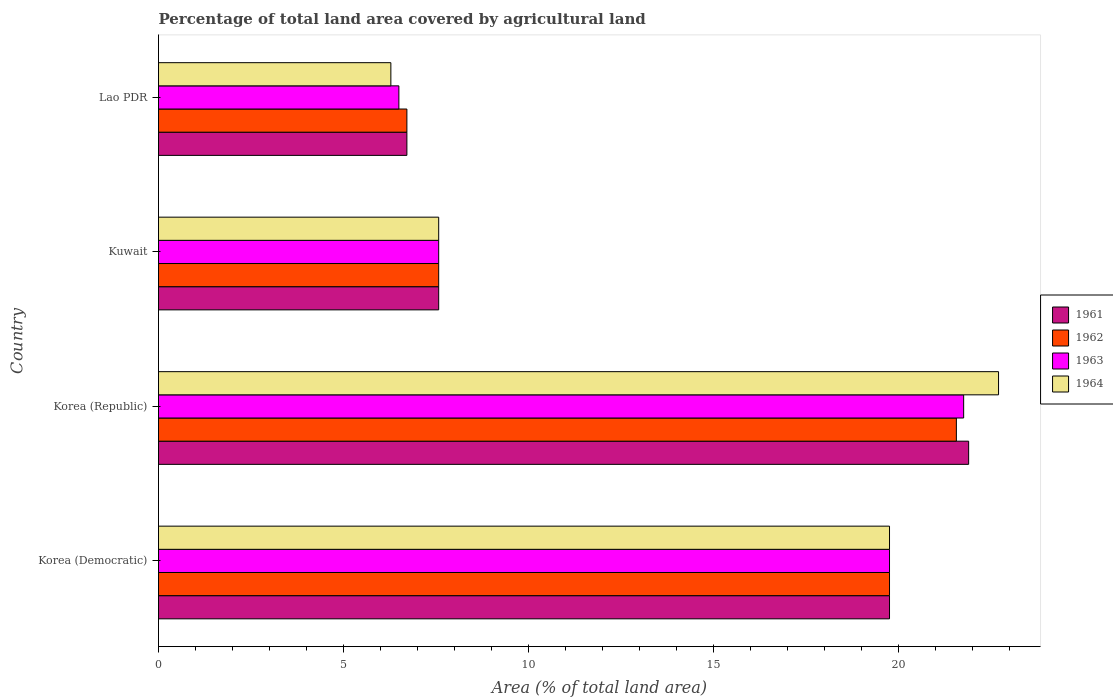How many different coloured bars are there?
Offer a very short reply. 4. Are the number of bars on each tick of the Y-axis equal?
Give a very brief answer. Yes. How many bars are there on the 1st tick from the bottom?
Provide a short and direct response. 4. What is the label of the 4th group of bars from the top?
Provide a succinct answer. Korea (Democratic). In how many cases, is the number of bars for a given country not equal to the number of legend labels?
Ensure brevity in your answer.  0. What is the percentage of agricultural land in 1963 in Kuwait?
Keep it short and to the point. 7.58. Across all countries, what is the maximum percentage of agricultural land in 1963?
Your response must be concise. 21.77. Across all countries, what is the minimum percentage of agricultural land in 1963?
Provide a short and direct response. 6.5. In which country was the percentage of agricultural land in 1961 maximum?
Your answer should be very brief. Korea (Republic). In which country was the percentage of agricultural land in 1964 minimum?
Provide a succinct answer. Lao PDR. What is the total percentage of agricultural land in 1964 in the graph?
Your answer should be compact. 56.34. What is the difference between the percentage of agricultural land in 1964 in Korea (Republic) and that in Lao PDR?
Make the answer very short. 16.43. What is the difference between the percentage of agricultural land in 1961 in Lao PDR and the percentage of agricultural land in 1963 in Kuwait?
Keep it short and to the point. -0.86. What is the average percentage of agricultural land in 1963 per country?
Offer a terse response. 13.9. What is the difference between the percentage of agricultural land in 1963 and percentage of agricultural land in 1964 in Korea (Republic)?
Keep it short and to the point. -0.94. In how many countries, is the percentage of agricultural land in 1964 greater than 5 %?
Provide a succinct answer. 4. What is the ratio of the percentage of agricultural land in 1962 in Korea (Democratic) to that in Kuwait?
Your answer should be very brief. 2.61. Is the percentage of agricultural land in 1962 in Korea (Democratic) less than that in Lao PDR?
Provide a short and direct response. No. What is the difference between the highest and the second highest percentage of agricultural land in 1963?
Your answer should be compact. 2. What is the difference between the highest and the lowest percentage of agricultural land in 1962?
Give a very brief answer. 14.86. What does the 3rd bar from the top in Korea (Democratic) represents?
Your response must be concise. 1962. What does the 4th bar from the bottom in Kuwait represents?
Keep it short and to the point. 1964. Are all the bars in the graph horizontal?
Give a very brief answer. Yes. How many countries are there in the graph?
Give a very brief answer. 4. What is the difference between two consecutive major ticks on the X-axis?
Keep it short and to the point. 5. How are the legend labels stacked?
Ensure brevity in your answer.  Vertical. What is the title of the graph?
Provide a short and direct response. Percentage of total land area covered by agricultural land. What is the label or title of the X-axis?
Give a very brief answer. Area (% of total land area). What is the Area (% of total land area) in 1961 in Korea (Democratic)?
Offer a very short reply. 19.77. What is the Area (% of total land area) of 1962 in Korea (Democratic)?
Provide a succinct answer. 19.77. What is the Area (% of total land area) in 1963 in Korea (Democratic)?
Give a very brief answer. 19.77. What is the Area (% of total land area) in 1964 in Korea (Democratic)?
Provide a succinct answer. 19.77. What is the Area (% of total land area) of 1961 in Korea (Republic)?
Offer a very short reply. 21.91. What is the Area (% of total land area) of 1962 in Korea (Republic)?
Your answer should be very brief. 21.57. What is the Area (% of total land area) in 1963 in Korea (Republic)?
Make the answer very short. 21.77. What is the Area (% of total land area) in 1964 in Korea (Republic)?
Provide a succinct answer. 22.71. What is the Area (% of total land area) of 1961 in Kuwait?
Keep it short and to the point. 7.58. What is the Area (% of total land area) of 1962 in Kuwait?
Provide a succinct answer. 7.58. What is the Area (% of total land area) in 1963 in Kuwait?
Your response must be concise. 7.58. What is the Area (% of total land area) of 1964 in Kuwait?
Give a very brief answer. 7.58. What is the Area (% of total land area) in 1961 in Lao PDR?
Your answer should be compact. 6.72. What is the Area (% of total land area) of 1962 in Lao PDR?
Ensure brevity in your answer.  6.72. What is the Area (% of total land area) in 1963 in Lao PDR?
Offer a terse response. 6.5. What is the Area (% of total land area) in 1964 in Lao PDR?
Keep it short and to the point. 6.28. Across all countries, what is the maximum Area (% of total land area) of 1961?
Provide a succinct answer. 21.91. Across all countries, what is the maximum Area (% of total land area) in 1962?
Give a very brief answer. 21.57. Across all countries, what is the maximum Area (% of total land area) in 1963?
Offer a terse response. 21.77. Across all countries, what is the maximum Area (% of total land area) in 1964?
Your answer should be compact. 22.71. Across all countries, what is the minimum Area (% of total land area) in 1961?
Ensure brevity in your answer.  6.72. Across all countries, what is the minimum Area (% of total land area) in 1962?
Provide a short and direct response. 6.72. Across all countries, what is the minimum Area (% of total land area) in 1963?
Provide a succinct answer. 6.5. Across all countries, what is the minimum Area (% of total land area) of 1964?
Give a very brief answer. 6.28. What is the total Area (% of total land area) in 1961 in the graph?
Your answer should be compact. 55.96. What is the total Area (% of total land area) of 1962 in the graph?
Your answer should be compact. 55.63. What is the total Area (% of total land area) of 1963 in the graph?
Your response must be concise. 55.61. What is the total Area (% of total land area) of 1964 in the graph?
Offer a terse response. 56.34. What is the difference between the Area (% of total land area) in 1961 in Korea (Democratic) and that in Korea (Republic)?
Keep it short and to the point. -2.14. What is the difference between the Area (% of total land area) of 1962 in Korea (Democratic) and that in Korea (Republic)?
Offer a terse response. -1.81. What is the difference between the Area (% of total land area) of 1963 in Korea (Democratic) and that in Korea (Republic)?
Make the answer very short. -2. What is the difference between the Area (% of total land area) of 1964 in Korea (Democratic) and that in Korea (Republic)?
Your answer should be very brief. -2.95. What is the difference between the Area (% of total land area) in 1961 in Korea (Democratic) and that in Kuwait?
Provide a succinct answer. 12.19. What is the difference between the Area (% of total land area) of 1962 in Korea (Democratic) and that in Kuwait?
Keep it short and to the point. 12.19. What is the difference between the Area (% of total land area) in 1963 in Korea (Democratic) and that in Kuwait?
Your answer should be compact. 12.19. What is the difference between the Area (% of total land area) in 1964 in Korea (Democratic) and that in Kuwait?
Offer a terse response. 12.19. What is the difference between the Area (% of total land area) of 1961 in Korea (Democratic) and that in Lao PDR?
Give a very brief answer. 13.05. What is the difference between the Area (% of total land area) of 1962 in Korea (Democratic) and that in Lao PDR?
Offer a terse response. 13.05. What is the difference between the Area (% of total land area) in 1963 in Korea (Democratic) and that in Lao PDR?
Give a very brief answer. 13.27. What is the difference between the Area (% of total land area) of 1964 in Korea (Democratic) and that in Lao PDR?
Provide a succinct answer. 13.48. What is the difference between the Area (% of total land area) of 1961 in Korea (Republic) and that in Kuwait?
Your answer should be very brief. 14.33. What is the difference between the Area (% of total land area) in 1962 in Korea (Republic) and that in Kuwait?
Provide a short and direct response. 14. What is the difference between the Area (% of total land area) of 1963 in Korea (Republic) and that in Kuwait?
Offer a very short reply. 14.19. What is the difference between the Area (% of total land area) of 1964 in Korea (Republic) and that in Kuwait?
Your response must be concise. 15.14. What is the difference between the Area (% of total land area) of 1961 in Korea (Republic) and that in Lao PDR?
Your answer should be compact. 15.19. What is the difference between the Area (% of total land area) in 1962 in Korea (Republic) and that in Lao PDR?
Your answer should be compact. 14.86. What is the difference between the Area (% of total land area) of 1963 in Korea (Republic) and that in Lao PDR?
Your answer should be very brief. 15.27. What is the difference between the Area (% of total land area) of 1964 in Korea (Republic) and that in Lao PDR?
Give a very brief answer. 16.43. What is the difference between the Area (% of total land area) of 1961 in Kuwait and that in Lao PDR?
Your response must be concise. 0.86. What is the difference between the Area (% of total land area) of 1962 in Kuwait and that in Lao PDR?
Provide a short and direct response. 0.86. What is the difference between the Area (% of total land area) in 1963 in Kuwait and that in Lao PDR?
Provide a short and direct response. 1.08. What is the difference between the Area (% of total land area) in 1964 in Kuwait and that in Lao PDR?
Make the answer very short. 1.29. What is the difference between the Area (% of total land area) in 1961 in Korea (Democratic) and the Area (% of total land area) in 1962 in Korea (Republic)?
Provide a short and direct response. -1.81. What is the difference between the Area (% of total land area) of 1961 in Korea (Democratic) and the Area (% of total land area) of 1963 in Korea (Republic)?
Your response must be concise. -2. What is the difference between the Area (% of total land area) in 1961 in Korea (Democratic) and the Area (% of total land area) in 1964 in Korea (Republic)?
Make the answer very short. -2.95. What is the difference between the Area (% of total land area) in 1962 in Korea (Democratic) and the Area (% of total land area) in 1963 in Korea (Republic)?
Your answer should be very brief. -2. What is the difference between the Area (% of total land area) of 1962 in Korea (Democratic) and the Area (% of total land area) of 1964 in Korea (Republic)?
Your response must be concise. -2.95. What is the difference between the Area (% of total land area) of 1963 in Korea (Democratic) and the Area (% of total land area) of 1964 in Korea (Republic)?
Offer a terse response. -2.95. What is the difference between the Area (% of total land area) in 1961 in Korea (Democratic) and the Area (% of total land area) in 1962 in Kuwait?
Offer a terse response. 12.19. What is the difference between the Area (% of total land area) in 1961 in Korea (Democratic) and the Area (% of total land area) in 1963 in Kuwait?
Your response must be concise. 12.19. What is the difference between the Area (% of total land area) in 1961 in Korea (Democratic) and the Area (% of total land area) in 1964 in Kuwait?
Ensure brevity in your answer.  12.19. What is the difference between the Area (% of total land area) in 1962 in Korea (Democratic) and the Area (% of total land area) in 1963 in Kuwait?
Your answer should be compact. 12.19. What is the difference between the Area (% of total land area) of 1962 in Korea (Democratic) and the Area (% of total land area) of 1964 in Kuwait?
Your response must be concise. 12.19. What is the difference between the Area (% of total land area) of 1963 in Korea (Democratic) and the Area (% of total land area) of 1964 in Kuwait?
Offer a terse response. 12.19. What is the difference between the Area (% of total land area) in 1961 in Korea (Democratic) and the Area (% of total land area) in 1962 in Lao PDR?
Offer a very short reply. 13.05. What is the difference between the Area (% of total land area) of 1961 in Korea (Democratic) and the Area (% of total land area) of 1963 in Lao PDR?
Your answer should be very brief. 13.27. What is the difference between the Area (% of total land area) of 1961 in Korea (Democratic) and the Area (% of total land area) of 1964 in Lao PDR?
Offer a terse response. 13.48. What is the difference between the Area (% of total land area) of 1962 in Korea (Democratic) and the Area (% of total land area) of 1963 in Lao PDR?
Provide a short and direct response. 13.27. What is the difference between the Area (% of total land area) of 1962 in Korea (Democratic) and the Area (% of total land area) of 1964 in Lao PDR?
Your response must be concise. 13.48. What is the difference between the Area (% of total land area) in 1963 in Korea (Democratic) and the Area (% of total land area) in 1964 in Lao PDR?
Provide a short and direct response. 13.48. What is the difference between the Area (% of total land area) in 1961 in Korea (Republic) and the Area (% of total land area) in 1962 in Kuwait?
Make the answer very short. 14.33. What is the difference between the Area (% of total land area) of 1961 in Korea (Republic) and the Area (% of total land area) of 1963 in Kuwait?
Give a very brief answer. 14.33. What is the difference between the Area (% of total land area) of 1961 in Korea (Republic) and the Area (% of total land area) of 1964 in Kuwait?
Keep it short and to the point. 14.33. What is the difference between the Area (% of total land area) in 1962 in Korea (Republic) and the Area (% of total land area) in 1963 in Kuwait?
Your answer should be compact. 14. What is the difference between the Area (% of total land area) in 1962 in Korea (Republic) and the Area (% of total land area) in 1964 in Kuwait?
Ensure brevity in your answer.  14. What is the difference between the Area (% of total land area) of 1963 in Korea (Republic) and the Area (% of total land area) of 1964 in Kuwait?
Your answer should be very brief. 14.19. What is the difference between the Area (% of total land area) in 1961 in Korea (Republic) and the Area (% of total land area) in 1962 in Lao PDR?
Ensure brevity in your answer.  15.19. What is the difference between the Area (% of total land area) of 1961 in Korea (Republic) and the Area (% of total land area) of 1963 in Lao PDR?
Provide a succinct answer. 15.41. What is the difference between the Area (% of total land area) of 1961 in Korea (Republic) and the Area (% of total land area) of 1964 in Lao PDR?
Make the answer very short. 15.62. What is the difference between the Area (% of total land area) of 1962 in Korea (Republic) and the Area (% of total land area) of 1963 in Lao PDR?
Offer a terse response. 15.07. What is the difference between the Area (% of total land area) of 1962 in Korea (Republic) and the Area (% of total land area) of 1964 in Lao PDR?
Provide a short and direct response. 15.29. What is the difference between the Area (% of total land area) in 1963 in Korea (Republic) and the Area (% of total land area) in 1964 in Lao PDR?
Provide a succinct answer. 15.49. What is the difference between the Area (% of total land area) in 1961 in Kuwait and the Area (% of total land area) in 1962 in Lao PDR?
Make the answer very short. 0.86. What is the difference between the Area (% of total land area) in 1961 in Kuwait and the Area (% of total land area) in 1963 in Lao PDR?
Give a very brief answer. 1.08. What is the difference between the Area (% of total land area) of 1961 in Kuwait and the Area (% of total land area) of 1964 in Lao PDR?
Make the answer very short. 1.29. What is the difference between the Area (% of total land area) in 1962 in Kuwait and the Area (% of total land area) in 1963 in Lao PDR?
Provide a succinct answer. 1.08. What is the difference between the Area (% of total land area) in 1962 in Kuwait and the Area (% of total land area) in 1964 in Lao PDR?
Ensure brevity in your answer.  1.29. What is the difference between the Area (% of total land area) in 1963 in Kuwait and the Area (% of total land area) in 1964 in Lao PDR?
Your answer should be compact. 1.29. What is the average Area (% of total land area) of 1961 per country?
Give a very brief answer. 13.99. What is the average Area (% of total land area) of 1962 per country?
Ensure brevity in your answer.  13.91. What is the average Area (% of total land area) of 1963 per country?
Your answer should be very brief. 13.9. What is the average Area (% of total land area) of 1964 per country?
Offer a very short reply. 14.08. What is the difference between the Area (% of total land area) in 1961 and Area (% of total land area) in 1964 in Korea (Democratic)?
Offer a terse response. 0. What is the difference between the Area (% of total land area) of 1962 and Area (% of total land area) of 1963 in Korea (Democratic)?
Ensure brevity in your answer.  0. What is the difference between the Area (% of total land area) in 1962 and Area (% of total land area) in 1964 in Korea (Democratic)?
Your answer should be very brief. 0. What is the difference between the Area (% of total land area) in 1961 and Area (% of total land area) in 1962 in Korea (Republic)?
Provide a succinct answer. 0.33. What is the difference between the Area (% of total land area) of 1961 and Area (% of total land area) of 1963 in Korea (Republic)?
Provide a short and direct response. 0.13. What is the difference between the Area (% of total land area) of 1961 and Area (% of total land area) of 1964 in Korea (Republic)?
Give a very brief answer. -0.81. What is the difference between the Area (% of total land area) in 1962 and Area (% of total land area) in 1963 in Korea (Republic)?
Your response must be concise. -0.2. What is the difference between the Area (% of total land area) of 1962 and Area (% of total land area) of 1964 in Korea (Republic)?
Your answer should be compact. -1.14. What is the difference between the Area (% of total land area) of 1963 and Area (% of total land area) of 1964 in Korea (Republic)?
Your response must be concise. -0.94. What is the difference between the Area (% of total land area) of 1961 and Area (% of total land area) of 1963 in Kuwait?
Keep it short and to the point. 0. What is the difference between the Area (% of total land area) in 1961 and Area (% of total land area) in 1964 in Kuwait?
Keep it short and to the point. 0. What is the difference between the Area (% of total land area) of 1962 and Area (% of total land area) of 1964 in Kuwait?
Ensure brevity in your answer.  0. What is the difference between the Area (% of total land area) of 1963 and Area (% of total land area) of 1964 in Kuwait?
Offer a terse response. 0. What is the difference between the Area (% of total land area) of 1961 and Area (% of total land area) of 1962 in Lao PDR?
Provide a short and direct response. 0. What is the difference between the Area (% of total land area) of 1961 and Area (% of total land area) of 1963 in Lao PDR?
Your answer should be very brief. 0.22. What is the difference between the Area (% of total land area) in 1961 and Area (% of total land area) in 1964 in Lao PDR?
Ensure brevity in your answer.  0.43. What is the difference between the Area (% of total land area) in 1962 and Area (% of total land area) in 1963 in Lao PDR?
Offer a very short reply. 0.22. What is the difference between the Area (% of total land area) in 1962 and Area (% of total land area) in 1964 in Lao PDR?
Ensure brevity in your answer.  0.43. What is the difference between the Area (% of total land area) of 1963 and Area (% of total land area) of 1964 in Lao PDR?
Offer a very short reply. 0.22. What is the ratio of the Area (% of total land area) in 1961 in Korea (Democratic) to that in Korea (Republic)?
Your answer should be very brief. 0.9. What is the ratio of the Area (% of total land area) in 1962 in Korea (Democratic) to that in Korea (Republic)?
Offer a very short reply. 0.92. What is the ratio of the Area (% of total land area) of 1963 in Korea (Democratic) to that in Korea (Republic)?
Ensure brevity in your answer.  0.91. What is the ratio of the Area (% of total land area) of 1964 in Korea (Democratic) to that in Korea (Republic)?
Provide a succinct answer. 0.87. What is the ratio of the Area (% of total land area) in 1961 in Korea (Democratic) to that in Kuwait?
Ensure brevity in your answer.  2.61. What is the ratio of the Area (% of total land area) in 1962 in Korea (Democratic) to that in Kuwait?
Make the answer very short. 2.61. What is the ratio of the Area (% of total land area) of 1963 in Korea (Democratic) to that in Kuwait?
Make the answer very short. 2.61. What is the ratio of the Area (% of total land area) of 1964 in Korea (Democratic) to that in Kuwait?
Make the answer very short. 2.61. What is the ratio of the Area (% of total land area) of 1961 in Korea (Democratic) to that in Lao PDR?
Offer a terse response. 2.94. What is the ratio of the Area (% of total land area) of 1962 in Korea (Democratic) to that in Lao PDR?
Offer a terse response. 2.94. What is the ratio of the Area (% of total land area) in 1963 in Korea (Democratic) to that in Lao PDR?
Make the answer very short. 3.04. What is the ratio of the Area (% of total land area) of 1964 in Korea (Democratic) to that in Lao PDR?
Keep it short and to the point. 3.15. What is the ratio of the Area (% of total land area) of 1961 in Korea (Republic) to that in Kuwait?
Your answer should be very brief. 2.89. What is the ratio of the Area (% of total land area) in 1962 in Korea (Republic) to that in Kuwait?
Give a very brief answer. 2.85. What is the ratio of the Area (% of total land area) of 1963 in Korea (Republic) to that in Kuwait?
Offer a terse response. 2.87. What is the ratio of the Area (% of total land area) of 1964 in Korea (Republic) to that in Kuwait?
Your answer should be very brief. 3. What is the ratio of the Area (% of total land area) in 1961 in Korea (Republic) to that in Lao PDR?
Give a very brief answer. 3.26. What is the ratio of the Area (% of total land area) of 1962 in Korea (Republic) to that in Lao PDR?
Keep it short and to the point. 3.21. What is the ratio of the Area (% of total land area) of 1963 in Korea (Republic) to that in Lao PDR?
Offer a very short reply. 3.35. What is the ratio of the Area (% of total land area) in 1964 in Korea (Republic) to that in Lao PDR?
Your answer should be compact. 3.62. What is the ratio of the Area (% of total land area) of 1961 in Kuwait to that in Lao PDR?
Ensure brevity in your answer.  1.13. What is the ratio of the Area (% of total land area) in 1962 in Kuwait to that in Lao PDR?
Make the answer very short. 1.13. What is the ratio of the Area (% of total land area) in 1963 in Kuwait to that in Lao PDR?
Make the answer very short. 1.17. What is the ratio of the Area (% of total land area) in 1964 in Kuwait to that in Lao PDR?
Your answer should be compact. 1.21. What is the difference between the highest and the second highest Area (% of total land area) in 1961?
Offer a terse response. 2.14. What is the difference between the highest and the second highest Area (% of total land area) of 1962?
Your response must be concise. 1.81. What is the difference between the highest and the second highest Area (% of total land area) in 1963?
Keep it short and to the point. 2. What is the difference between the highest and the second highest Area (% of total land area) in 1964?
Offer a terse response. 2.95. What is the difference between the highest and the lowest Area (% of total land area) of 1961?
Keep it short and to the point. 15.19. What is the difference between the highest and the lowest Area (% of total land area) in 1962?
Offer a terse response. 14.86. What is the difference between the highest and the lowest Area (% of total land area) in 1963?
Your response must be concise. 15.27. What is the difference between the highest and the lowest Area (% of total land area) of 1964?
Keep it short and to the point. 16.43. 